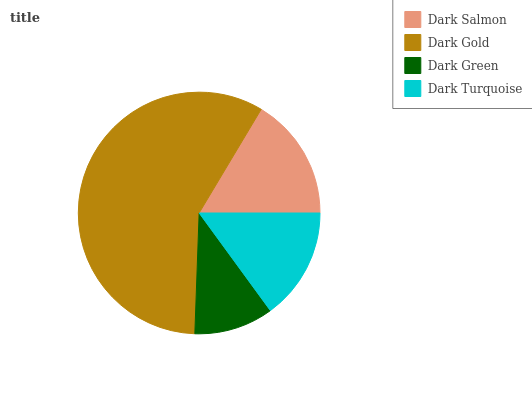Is Dark Green the minimum?
Answer yes or no. Yes. Is Dark Gold the maximum?
Answer yes or no. Yes. Is Dark Gold the minimum?
Answer yes or no. No. Is Dark Green the maximum?
Answer yes or no. No. Is Dark Gold greater than Dark Green?
Answer yes or no. Yes. Is Dark Green less than Dark Gold?
Answer yes or no. Yes. Is Dark Green greater than Dark Gold?
Answer yes or no. No. Is Dark Gold less than Dark Green?
Answer yes or no. No. Is Dark Salmon the high median?
Answer yes or no. Yes. Is Dark Turquoise the low median?
Answer yes or no. Yes. Is Dark Green the high median?
Answer yes or no. No. Is Dark Gold the low median?
Answer yes or no. No. 